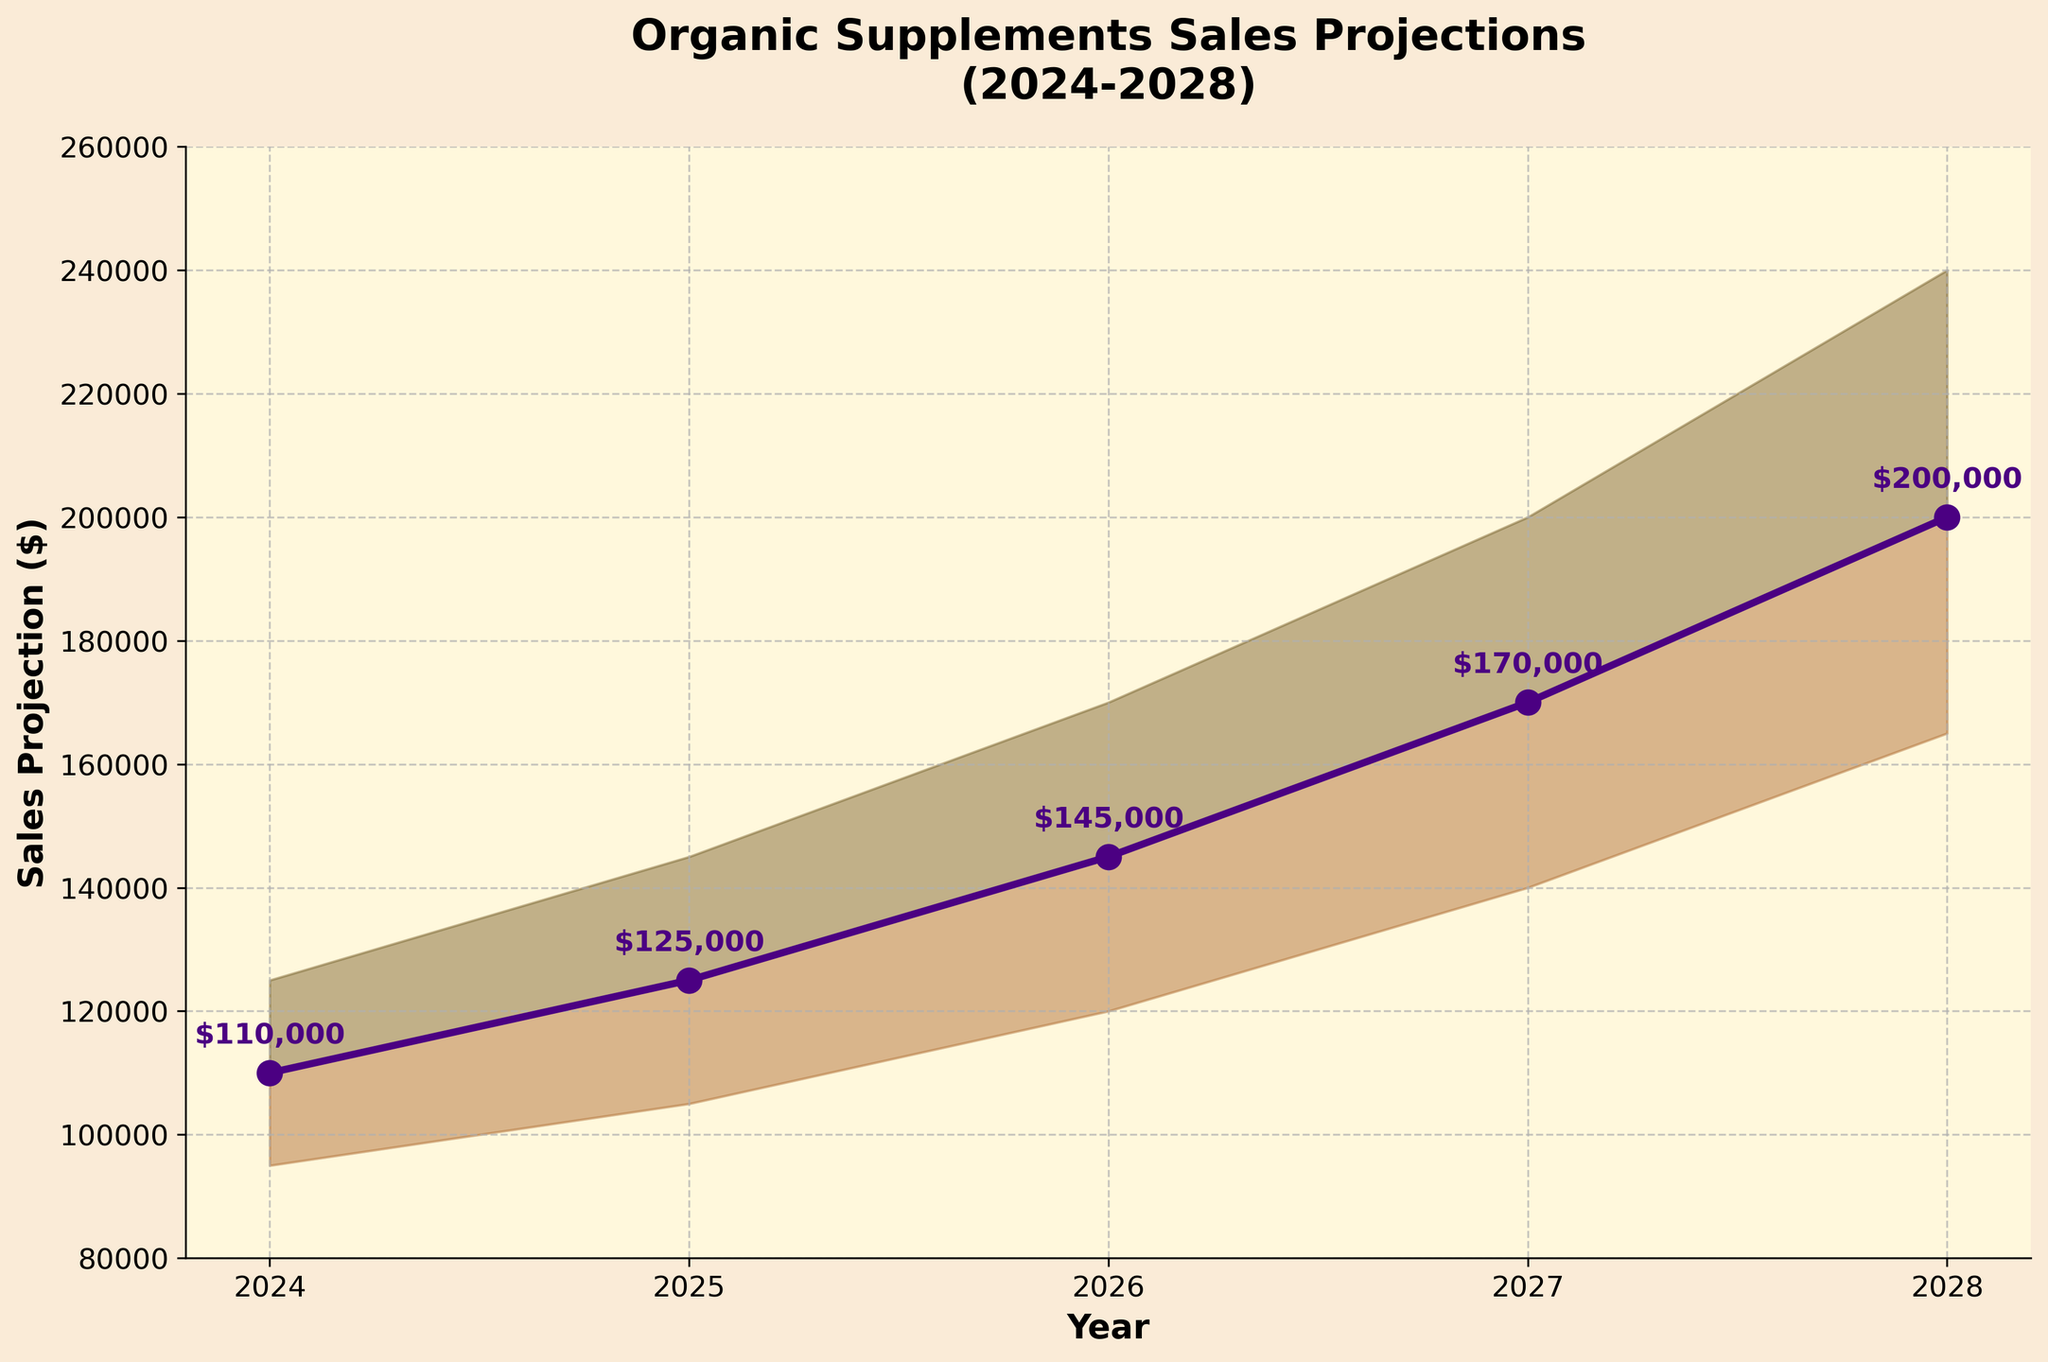What's the title of the figure? The title is located at the top of the figure, usually in larger and bolder font for easy identification.
Answer: Organic Supplements Sales Projections (2024-2028) What is the projected likely sales value for the year 2026? The likely sales values are marked by a line plot with markers. Locate the marker on the line for the year 2026 and read the value directly from it.
Answer: $145,000 What is the difference between the optimistic and pessimistic projections for 2028? To find the difference, subtract the pessimistic value from the optimistic value for the year 2028: 240,000 - 165,000 = 75,000
Answer: $75,000 Which year shows the highest optimistic projection? The year with the highest optimistic projection is determined by finding the maximum value in the optimistic plot. Identify the year corresponding to that value.
Answer: 2028 What trend can be observed in the likely sales projections from 2024 to 2028? To determine the trend, observe the slope of the likely sales line plot. The values steadily increase each year. This indicates an upward trend.
Answer: Increasing Between which two successive years is the growth in likely sales projection the smallest? Calculate the yearly growth by subtracting the likely sales value of the previous year from the next. Compare all yearly differences and identify the smallest one. Specifically: 2025-2024: 125,000-110,000 = 15,000, 2026-2025: 145,000-125,000 = 20,000, 2027-2026: 170,000-145,000 = 25,000, 2028-2027: 200,000-170,000 = 30,000. The smallest is 15,000 between 2024 and 2025.
Answer: Between 2024 and 2025 How does the color scheme differentiate between the optimistic and pessimistic ranges? The figure uses different shades and transparency in colors. The more optimistic ranges are highlighted with a lighter, greener shade, while the pessimistic ranges are highlighted with a darker, brownish shade.
Answer: Light green for optimistic, brown for pessimistic What is the percentage increase in the likely projection from 2024 to 2028? To find the percentage increase, calculate the difference between the two values (200,000 - 110,000), divide by the initial value (110,000), and multiply by 100: ((200,000 - 110,000) / 110,000) * 100 = 81.82%
Answer: 81.82% During which year does the gap between the optimistic and pessimistic projections become the widest? To find the widest gap, compare the gaps (difference) for each year: 2024: 125,000-95,000 = 30,000, 2025: 145,000-105,000 = 40,000, 2026: 170,000-120,000 = 50,000, 2027: 200,000-140,000 = 60,000, 2028: 240,000-165,000 = 75,000. The widest gap is in 2028.
Answer: 2028 